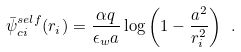Convert formula to latex. <formula><loc_0><loc_0><loc_500><loc_500>\bar { \psi } _ { c i } ^ { s e l f } ( { r } _ { i } ) = \frac { \alpha q } { \epsilon _ { w } a } \log \left ( 1 - \frac { a ^ { 2 } } { r _ { i } ^ { 2 } } \right ) \ .</formula> 